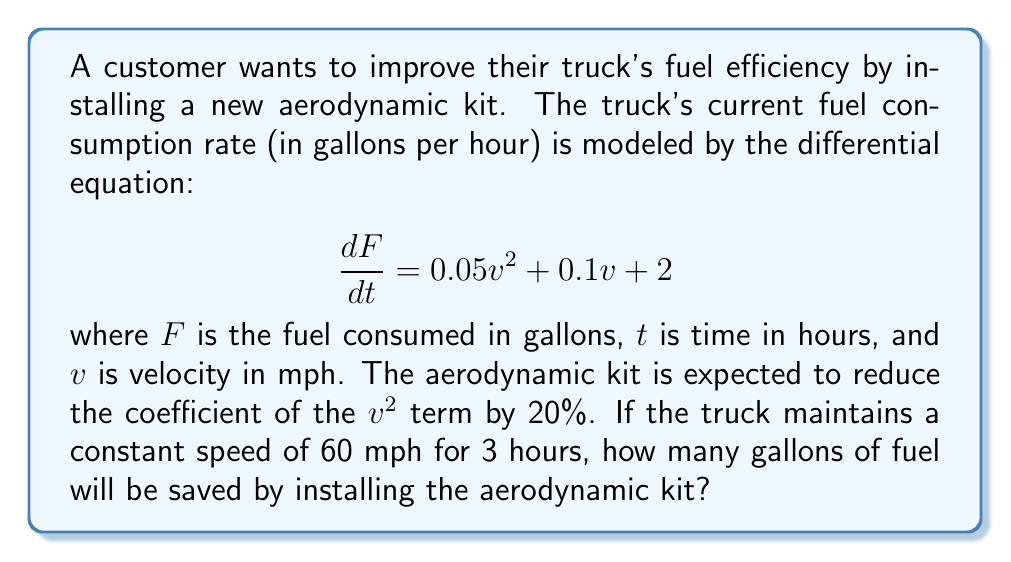Help me with this question. Let's approach this step-by-step:

1) First, let's calculate the fuel consumption without the aerodynamic kit:

   $$\frac{dF}{dt} = 0.05v^2 + 0.1v + 2$$
   At 60 mph: $$\frac{dF}{dt} = 0.05(60)^2 + 0.1(60) + 2 = 180 + 6 + 2 = 188$$ gallons per hour

2) Now, let's calculate the total fuel consumed over 3 hours:
   
   $$F = 188 \cdot 3 = 564$$ gallons

3) With the aerodynamic kit, the new equation becomes:

   $$\frac{dF}{dt} = 0.8(0.05v^2) + 0.1v + 2 = 0.04v^2 + 0.1v + 2$$

4) At 60 mph with the kit:

   $$\frac{dF}{dt} = 0.04(60)^2 + 0.1(60) + 2 = 144 + 6 + 2 = 152$$ gallons per hour

5) Total fuel consumed over 3 hours with the kit:

   $$F = 152 \cdot 3 = 456$$ gallons

6) Fuel saved:

   $$564 - 456 = 108$$ gallons
Answer: 108 gallons 